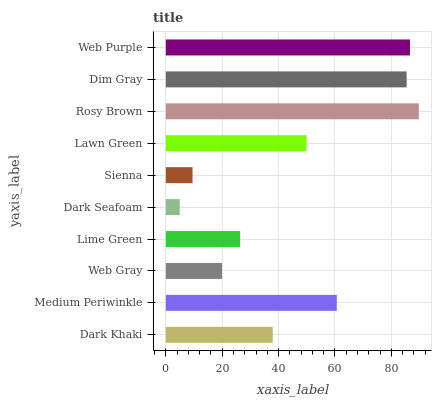Is Dark Seafoam the minimum?
Answer yes or no. Yes. Is Rosy Brown the maximum?
Answer yes or no. Yes. Is Medium Periwinkle the minimum?
Answer yes or no. No. Is Medium Periwinkle the maximum?
Answer yes or no. No. Is Medium Periwinkle greater than Dark Khaki?
Answer yes or no. Yes. Is Dark Khaki less than Medium Periwinkle?
Answer yes or no. Yes. Is Dark Khaki greater than Medium Periwinkle?
Answer yes or no. No. Is Medium Periwinkle less than Dark Khaki?
Answer yes or no. No. Is Lawn Green the high median?
Answer yes or no. Yes. Is Dark Khaki the low median?
Answer yes or no. Yes. Is Dark Seafoam the high median?
Answer yes or no. No. Is Web Gray the low median?
Answer yes or no. No. 